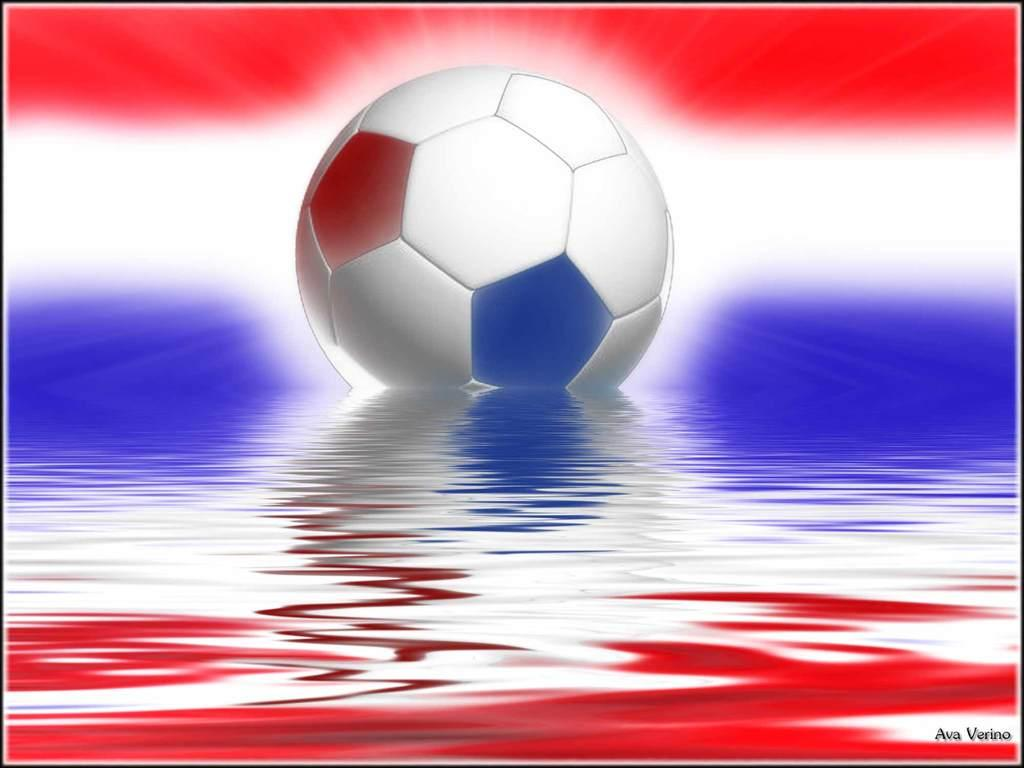What object is the main focus of the image? There is a ball in the image. Can you describe the position of the ball? The ball is on a surface in the image. What can be seen in the background of the image? There are different colors in the background of the image. Is there any text present in the image? Yes, there is text visible in the bottom right corner of the image. What type of milk is being poured onto the ball in the image? There is no milk present in the image, and the ball is not being interacted with in any way. Can you tell me how many wrenches are visible in the image? There are no wrenches present in the image; the main focus is on the ball. 